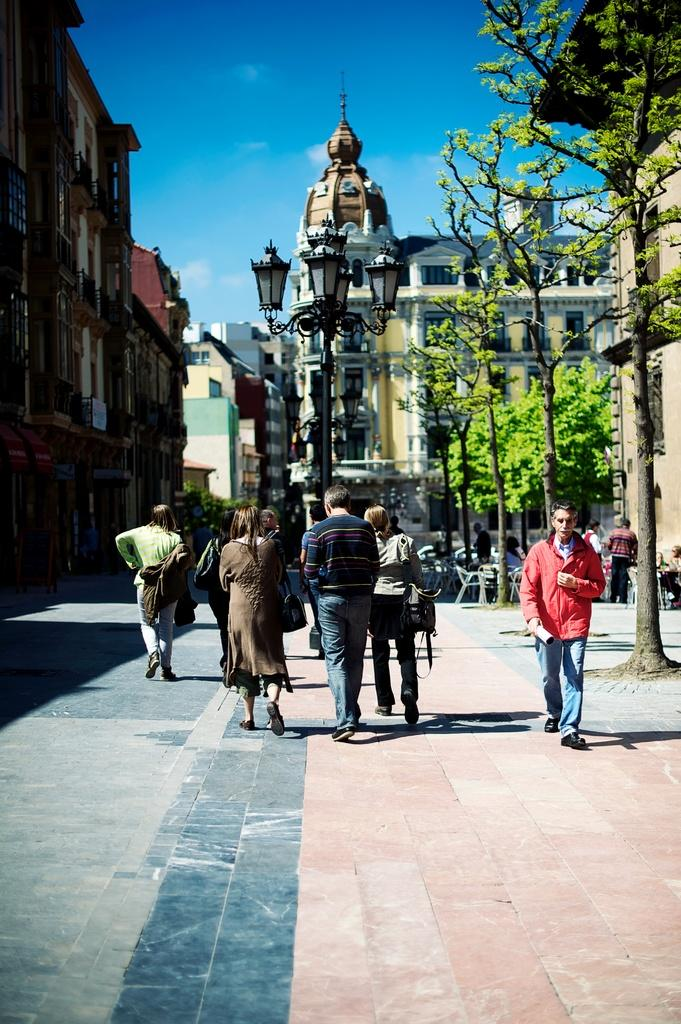What type of structures can be seen in the image? There are buildings in the image. What feature can be observed on the buildings? There are windows visible in the image. What type of vegetation is present in the image? There are trees in the image. What type of street furniture can be seen in the image? There are light poles in the image. What type of furniture is present in the image? There are chairs in the image. What activity can be observed in the image? There are people walking in the image. What color is the sky in the image? The sky is blue in color. What type of quilt is being used to cover the page in the image? There is no quilt or page present in the image. What statement can be made about the people walking in the image? The statement cannot be made based on the information provided in the image. 